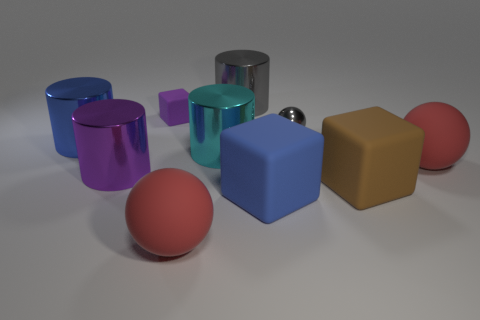Subtract all blue cylinders. How many cylinders are left? 3 Subtract all cyan cylinders. How many cylinders are left? 3 Subtract 2 cylinders. How many cylinders are left? 2 Subtract all yellow cylinders. Subtract all blue balls. How many cylinders are left? 4 Subtract all cubes. How many objects are left? 7 Subtract 1 blue cubes. How many objects are left? 9 Subtract all big metal objects. Subtract all large cyan things. How many objects are left? 5 Add 5 cyan shiny cylinders. How many cyan shiny cylinders are left? 6 Add 7 large cyan shiny cylinders. How many large cyan shiny cylinders exist? 8 